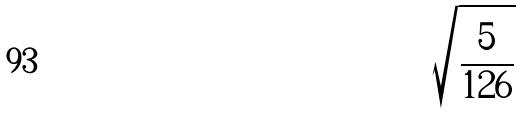Convert formula to latex. <formula><loc_0><loc_0><loc_500><loc_500>\sqrt { \frac { 5 } { 1 2 6 } }</formula> 